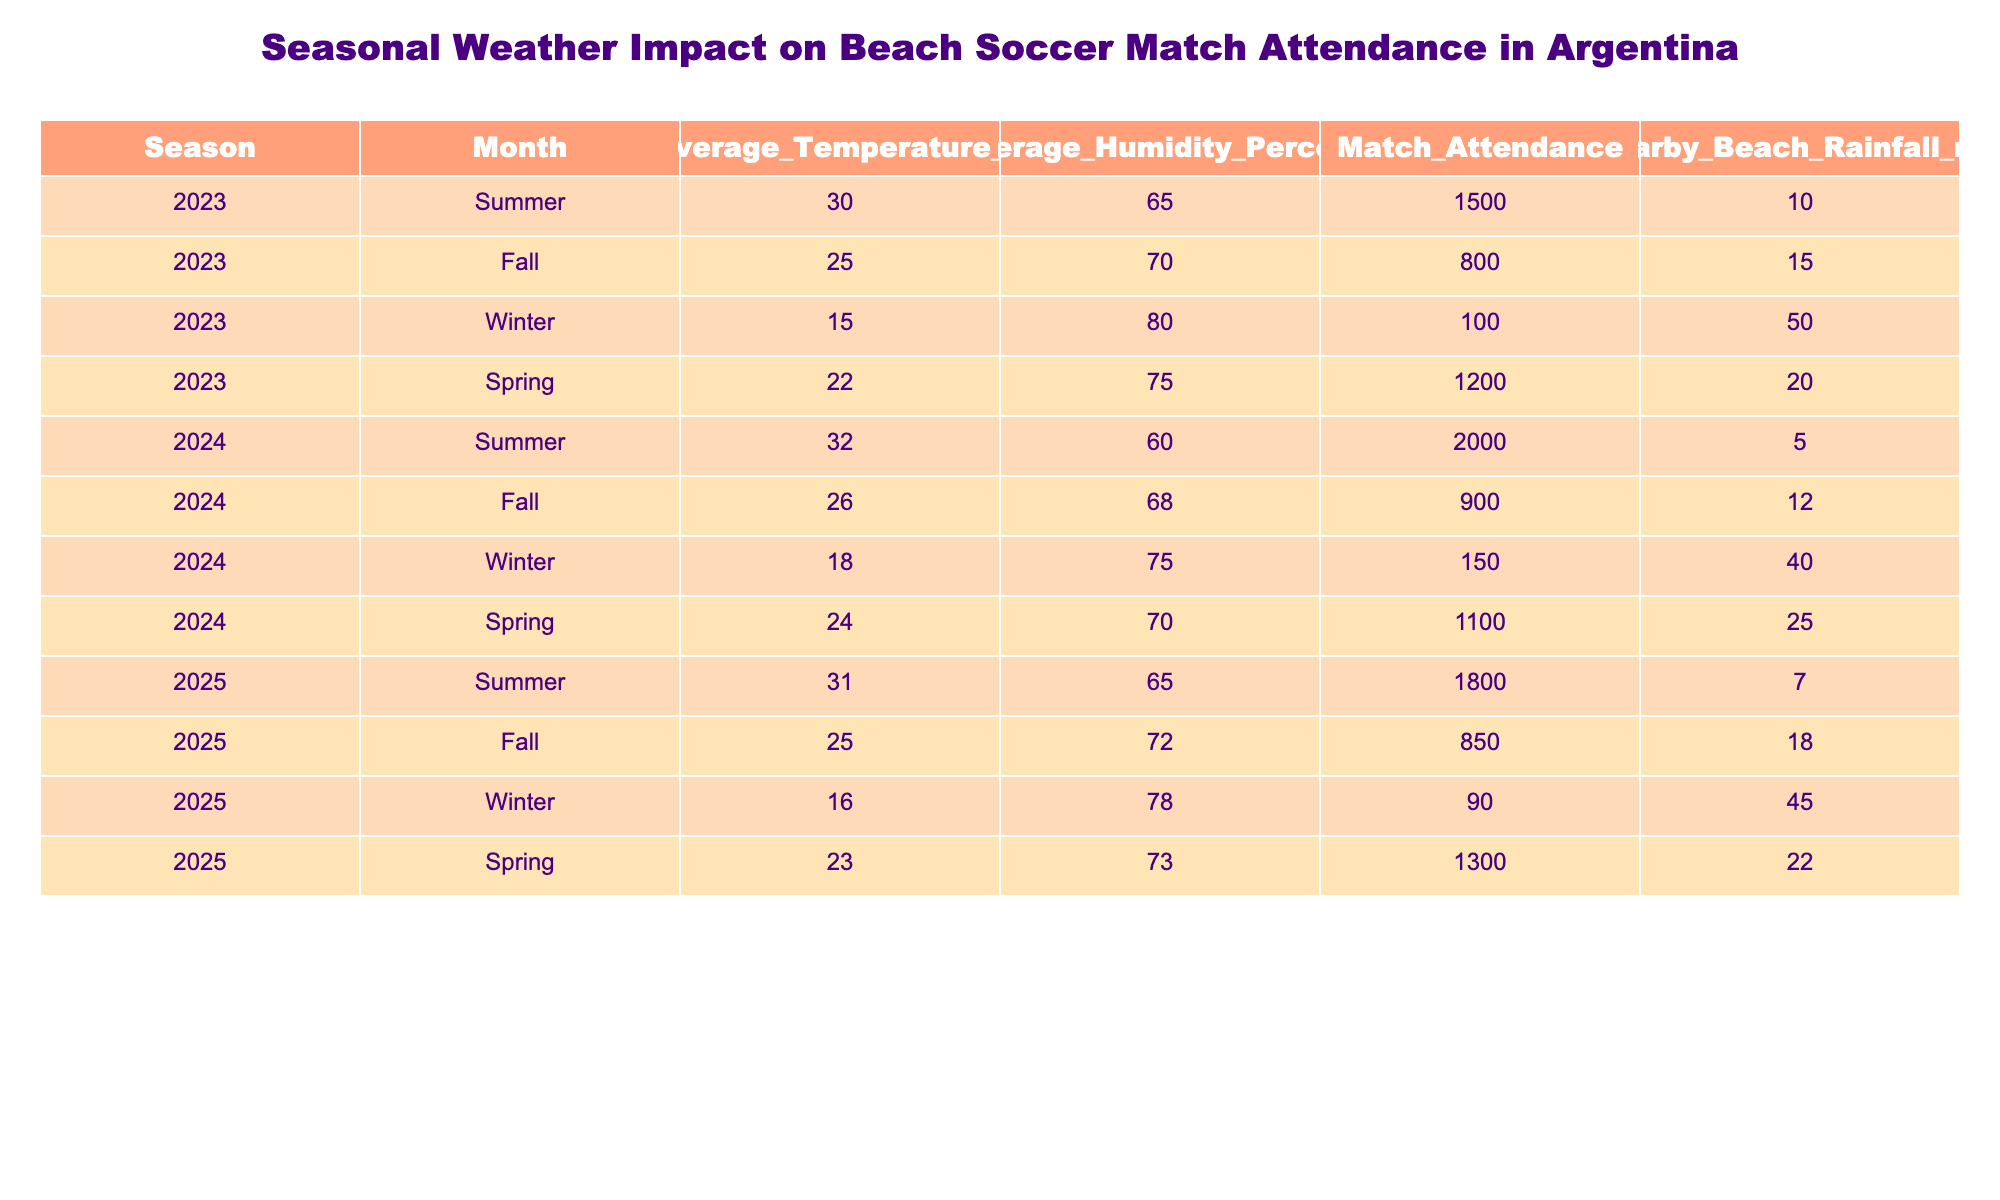What is the match attendance during Summer in 2023? The table shows the match attendance for Summer in 2023 is listed as 1500.
Answer: 1500 What is the average temperature during Fall in 2024? The entry for Fall in 2024 states that the average temperature is 26°C.
Answer: 26°C What is the difference in match attendance between Winter 2023 and Winter 2025? The match attendance for Winter 2023 is 100, and for Winter 2025, it is 90. The difference is 100 - 90 = 10.
Answer: 10 Which season in 2024 had the highest match attendance, and what was it? The table indicates Summer 2024 had the highest attendance at 2000.
Answer: Summer 2024, 2000 What is the average humidity percentage across all seasons in 2023? The average humidity percentages for 2023 are 65, 70, 80, and 75. Summing these gives 290, and dividing by 4 seasons provides an average of 72.5%.
Answer: 72.5% Is there a correlation between average temperature and match attendance in Winter? In Winter, the average temperatures were 15°C in 2023 and 18°C in 2024, with attendance of 100 and 150, respectively. This shows a slight positive correlation; both temperatures increased with attendance but isn't definitive without analysis.
Answer: No Which season had the least rainfall in 2025? The rainfall data shows that Summer 2025 had the least, at only 7 mm.
Answer: Summer 2025 What is the average match attendance for Spring across the years? The Spring match attendances are 1200 (2023), 1100 (2024), and 1300 (2025). Adding these gives 3600, and dividing by 3 gives an average of 1200.
Answer: 1200 Did match attendance increase from 2023 to 2024 during Fall? The Fall attendance in 2023 was 800, while in 2024 it was 900. Since 900 is greater than 800, it confirms an increase.
Answer: Yes What is the relationship between average humidity and nearby beach rainfall for Winter 2024 and Spring 2024? For Winter 2024, the average humidity is 75% with 40 mm rainfall, and for Spring 2024, it's 70% with 25 mm rainfall. The higher humidity corresponds to more rainfall in Winter and less in Spring contextually.
Answer: Higher humidity in Winter corresponds to more rainfall 